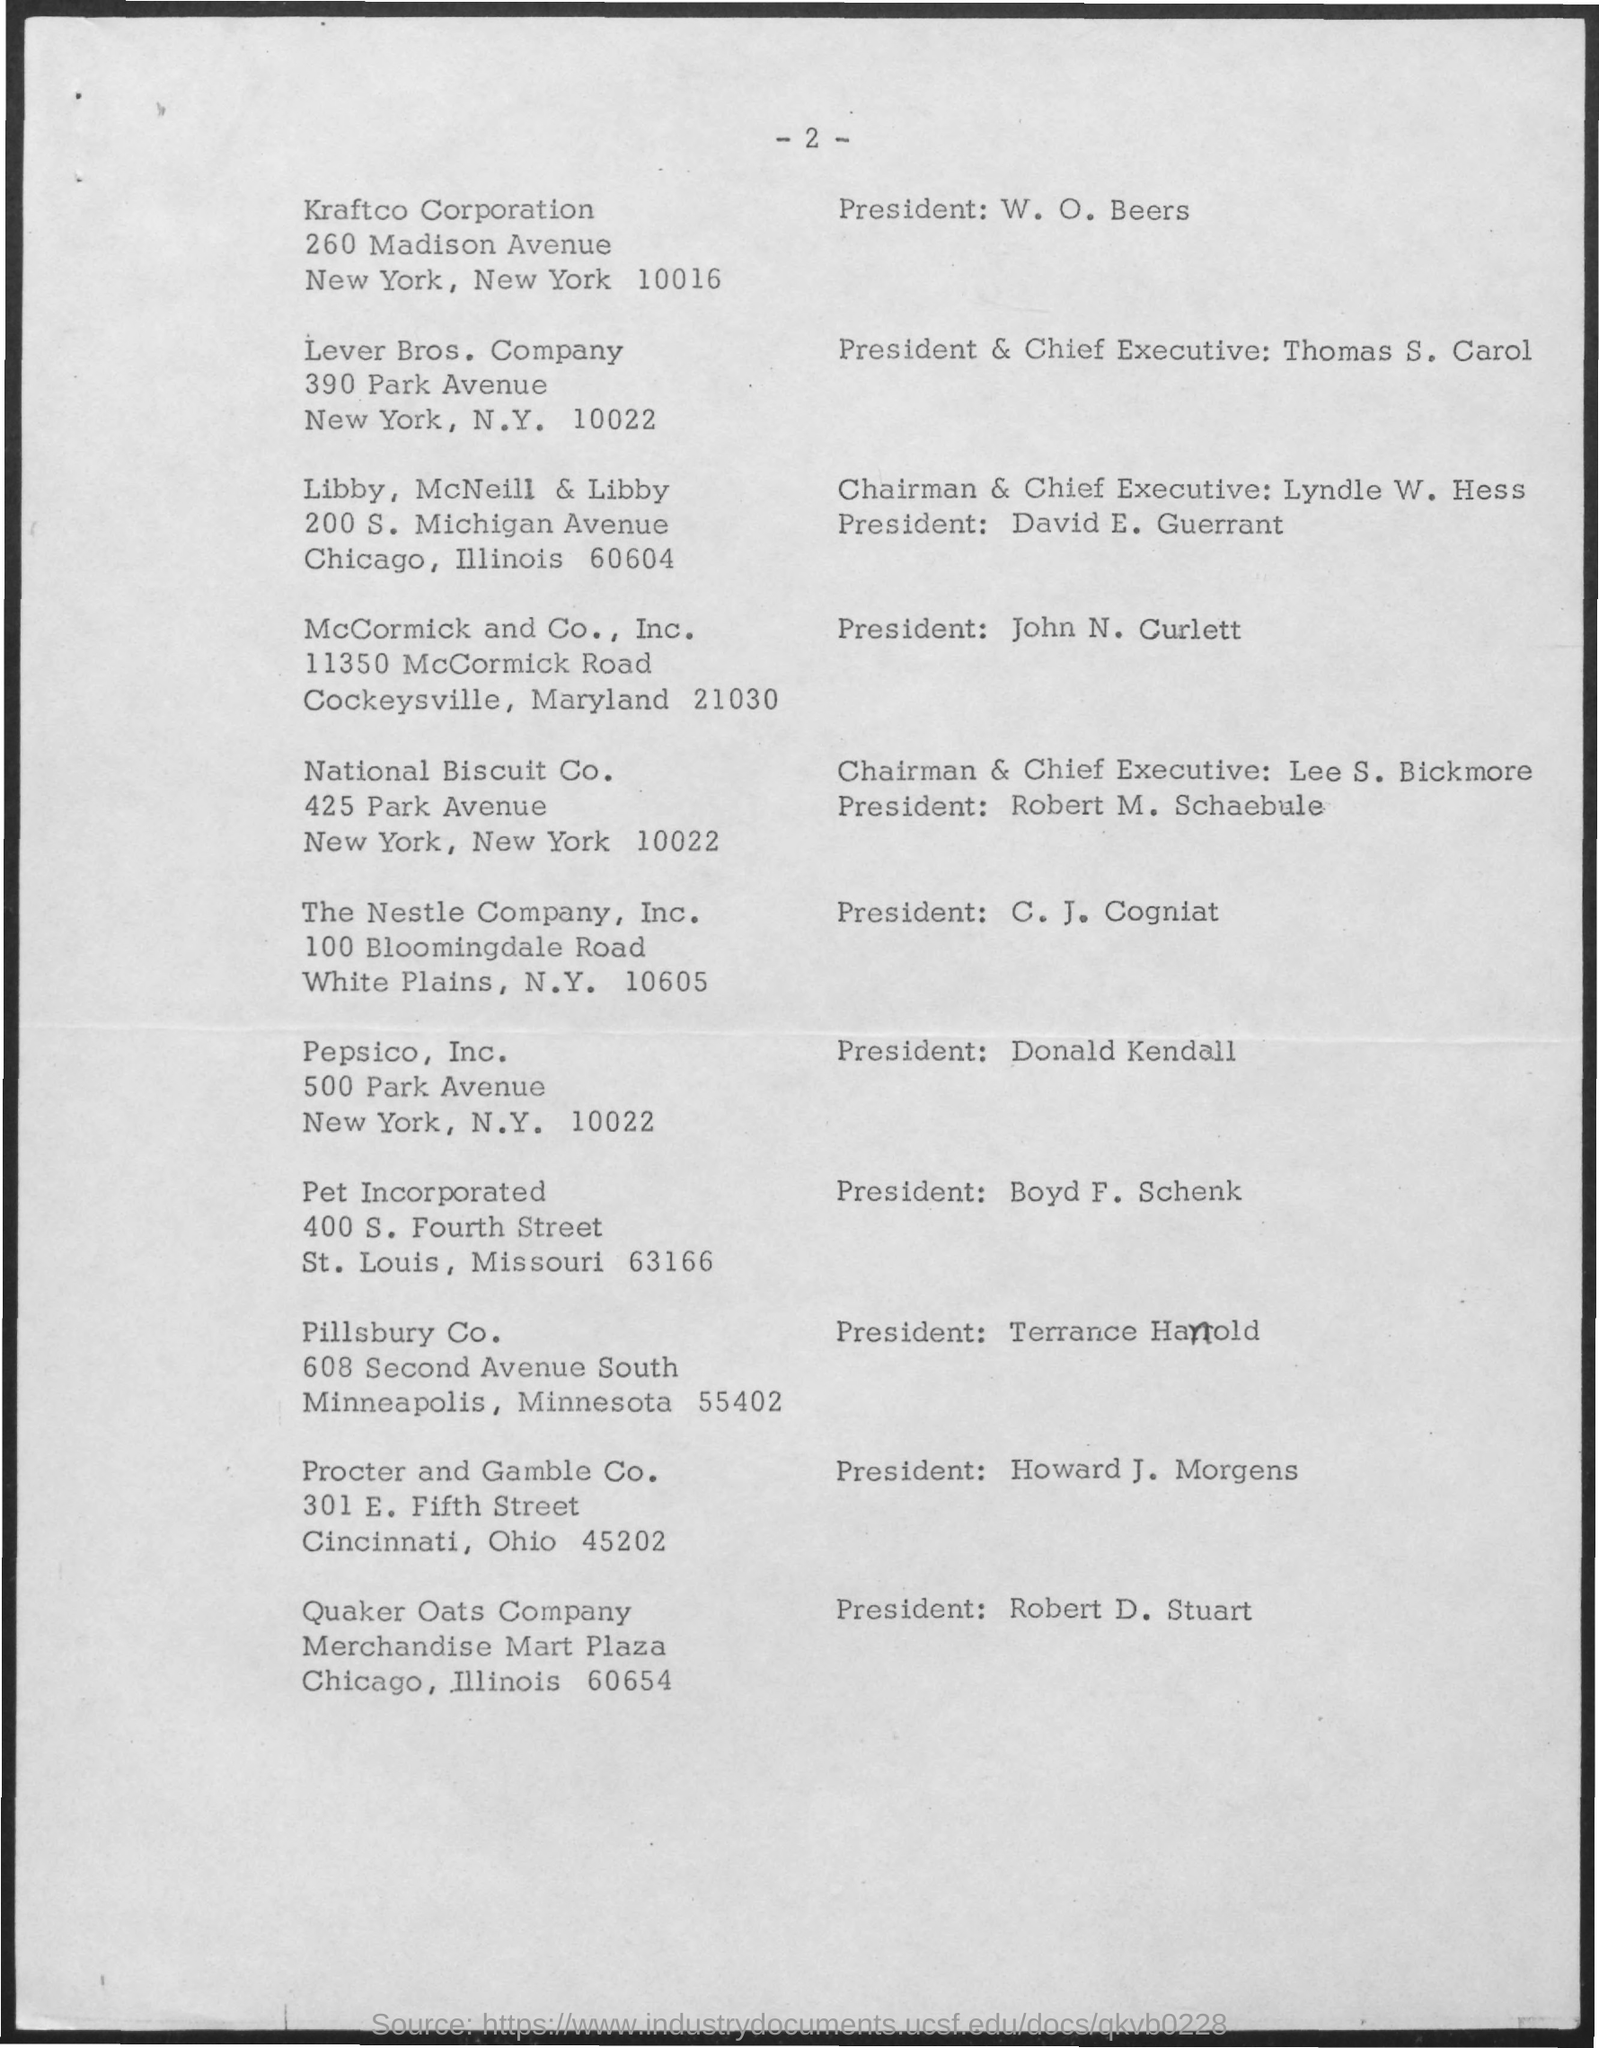Who is the president of kraft co corporation ?
Give a very brief answer. W. O. Beers. Who is the president & chief executive of lever bros. company ?
Give a very brief answer. Thomas S. Carol. Who is the chairman and chief executive of libby , mcneill &libby ?
Offer a very short reply. Lyndle W. Hess. Who is the president of the nestle company,inc ?
Give a very brief answer. C . J. Cogniat. Who is the president of pepsico ,inc. ?
Offer a terse response. Donald Kendall. Who is the president of pillsbury co. ?
Make the answer very short. Terrance Hanold. Who is the president of quaker oats company ?
Your answer should be very brief. Robert D. Stuart. Who is the president for procter and gamble co. ?
Your answer should be compact. Howard J. Morgens. Who is the chairman and chief executive of national biscuit co. ?
Give a very brief answer. Lee S. Bickmore. 